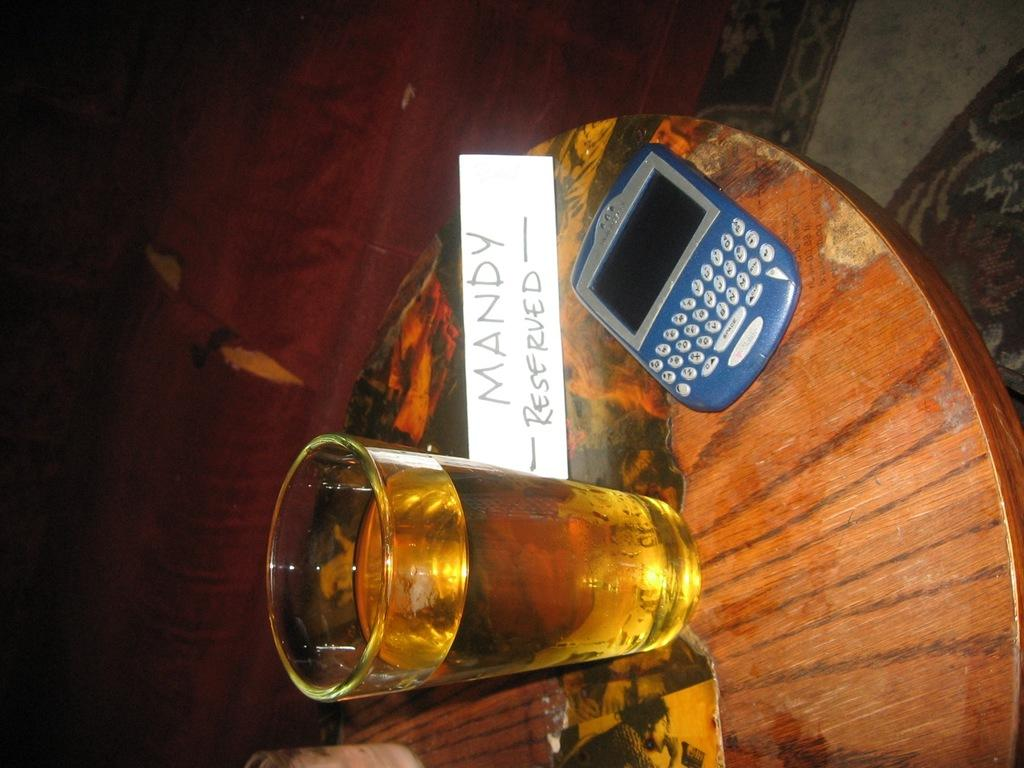What piece of furniture is present in the image? There is a table in the image. What is on the table? There is a glass with liquid on the table, as well as a name board and a mobile. What type of cannon is present on the table in the image? There is no cannon present on the table in the image. What need is being addressed by the items on the table in the image? The items on the table in the image do not address a specific need; they are simply objects that are present. 